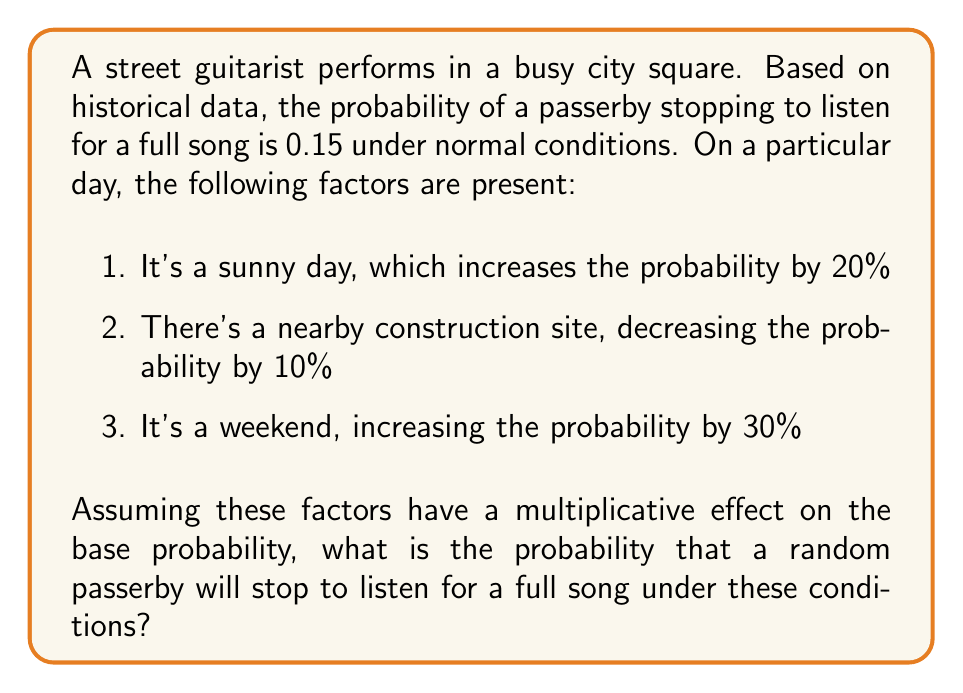Show me your answer to this math problem. Let's approach this step-by-step:

1) First, we start with the base probability:
   $P(\text{base}) = 0.15$

2) Now, we need to account for each factor:
   - Sunny day: increases by 20%, so we multiply by 1.20
   - Construction site: decreases by 10%, so we multiply by 0.90
   - Weekend: increases by 30%, so we multiply by 1.30

3) We apply these factors multiplicatively:
   $P(\text{adjusted}) = P(\text{base}) \times 1.20 \times 0.90 \times 1.30$

4) Let's calculate:
   $P(\text{adjusted}) = 0.15 \times 1.20 \times 0.90 \times 1.30$
   
   $= 0.15 \times 1.404$
   
   $= 0.2106$

5) Therefore, the probability of a passerby stopping to listen for a full song under these conditions is approximately 0.2106 or 21.06%.
Answer: 0.2106 